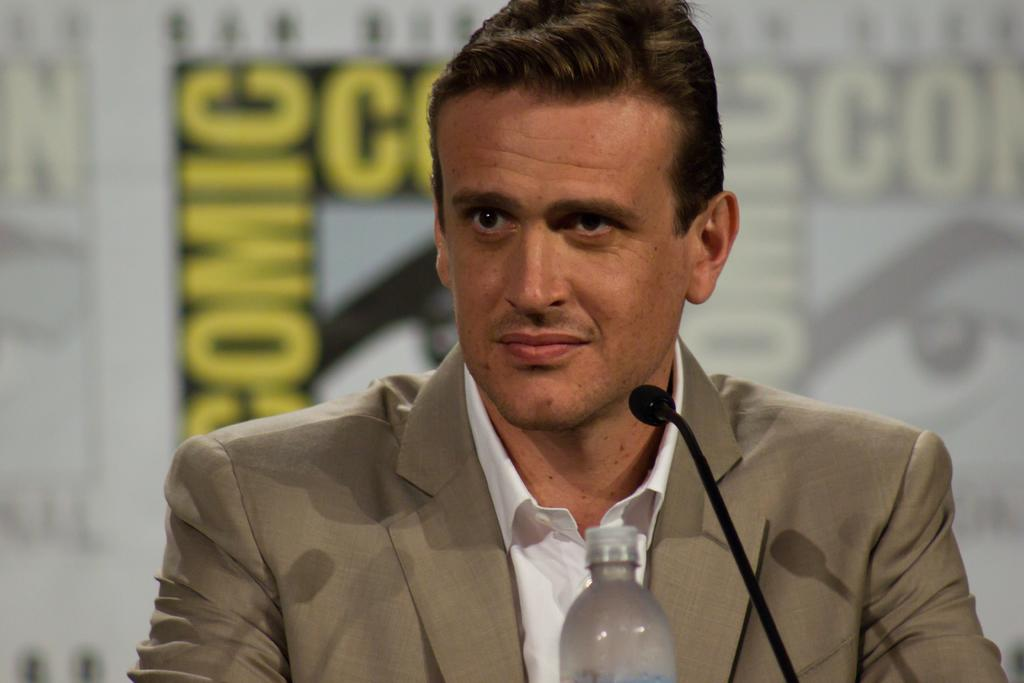Who is present in the image? There is a man in the image. What is the man doing in the image? The man is sitting in the image. What object is the man interacting with in the image? The man is in front of a microphone in the image. What other item can be seen in the image? There is a bottle in the image. What can be seen in the background of the image? There are hoardings in the background of the image. What type of branch can be seen hanging from the microphone in the image? There is no branch hanging from the microphone in the image. What sound do the bells make in the image? There are no bells present in the image. 